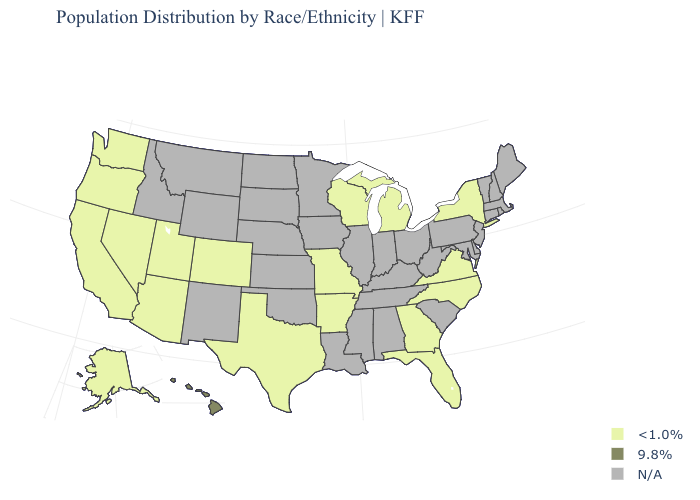What is the highest value in the West ?
Quick response, please. 9.8%. Name the states that have a value in the range 9.8%?
Short answer required. Hawaii. Name the states that have a value in the range N/A?
Quick response, please. Alabama, Connecticut, Delaware, Idaho, Illinois, Indiana, Iowa, Kansas, Kentucky, Louisiana, Maine, Maryland, Massachusetts, Minnesota, Mississippi, Montana, Nebraska, New Hampshire, New Jersey, New Mexico, North Dakota, Ohio, Oklahoma, Pennsylvania, Rhode Island, South Carolina, South Dakota, Tennessee, Vermont, West Virginia, Wyoming. What is the value of Iowa?
Give a very brief answer. N/A. Is the legend a continuous bar?
Write a very short answer. No. Name the states that have a value in the range 9.8%?
Quick response, please. Hawaii. What is the lowest value in the USA?
Answer briefly. <1.0%. What is the lowest value in states that border Vermont?
Answer briefly. <1.0%. What is the highest value in the West ?
Short answer required. 9.8%. Does the map have missing data?
Write a very short answer. Yes. What is the value of California?
Keep it brief. <1.0%. Name the states that have a value in the range 9.8%?
Keep it brief. Hawaii. What is the value of Texas?
Keep it brief. <1.0%. What is the lowest value in the USA?
Quick response, please. <1.0%. Does Wisconsin have the highest value in the USA?
Short answer required. No. 